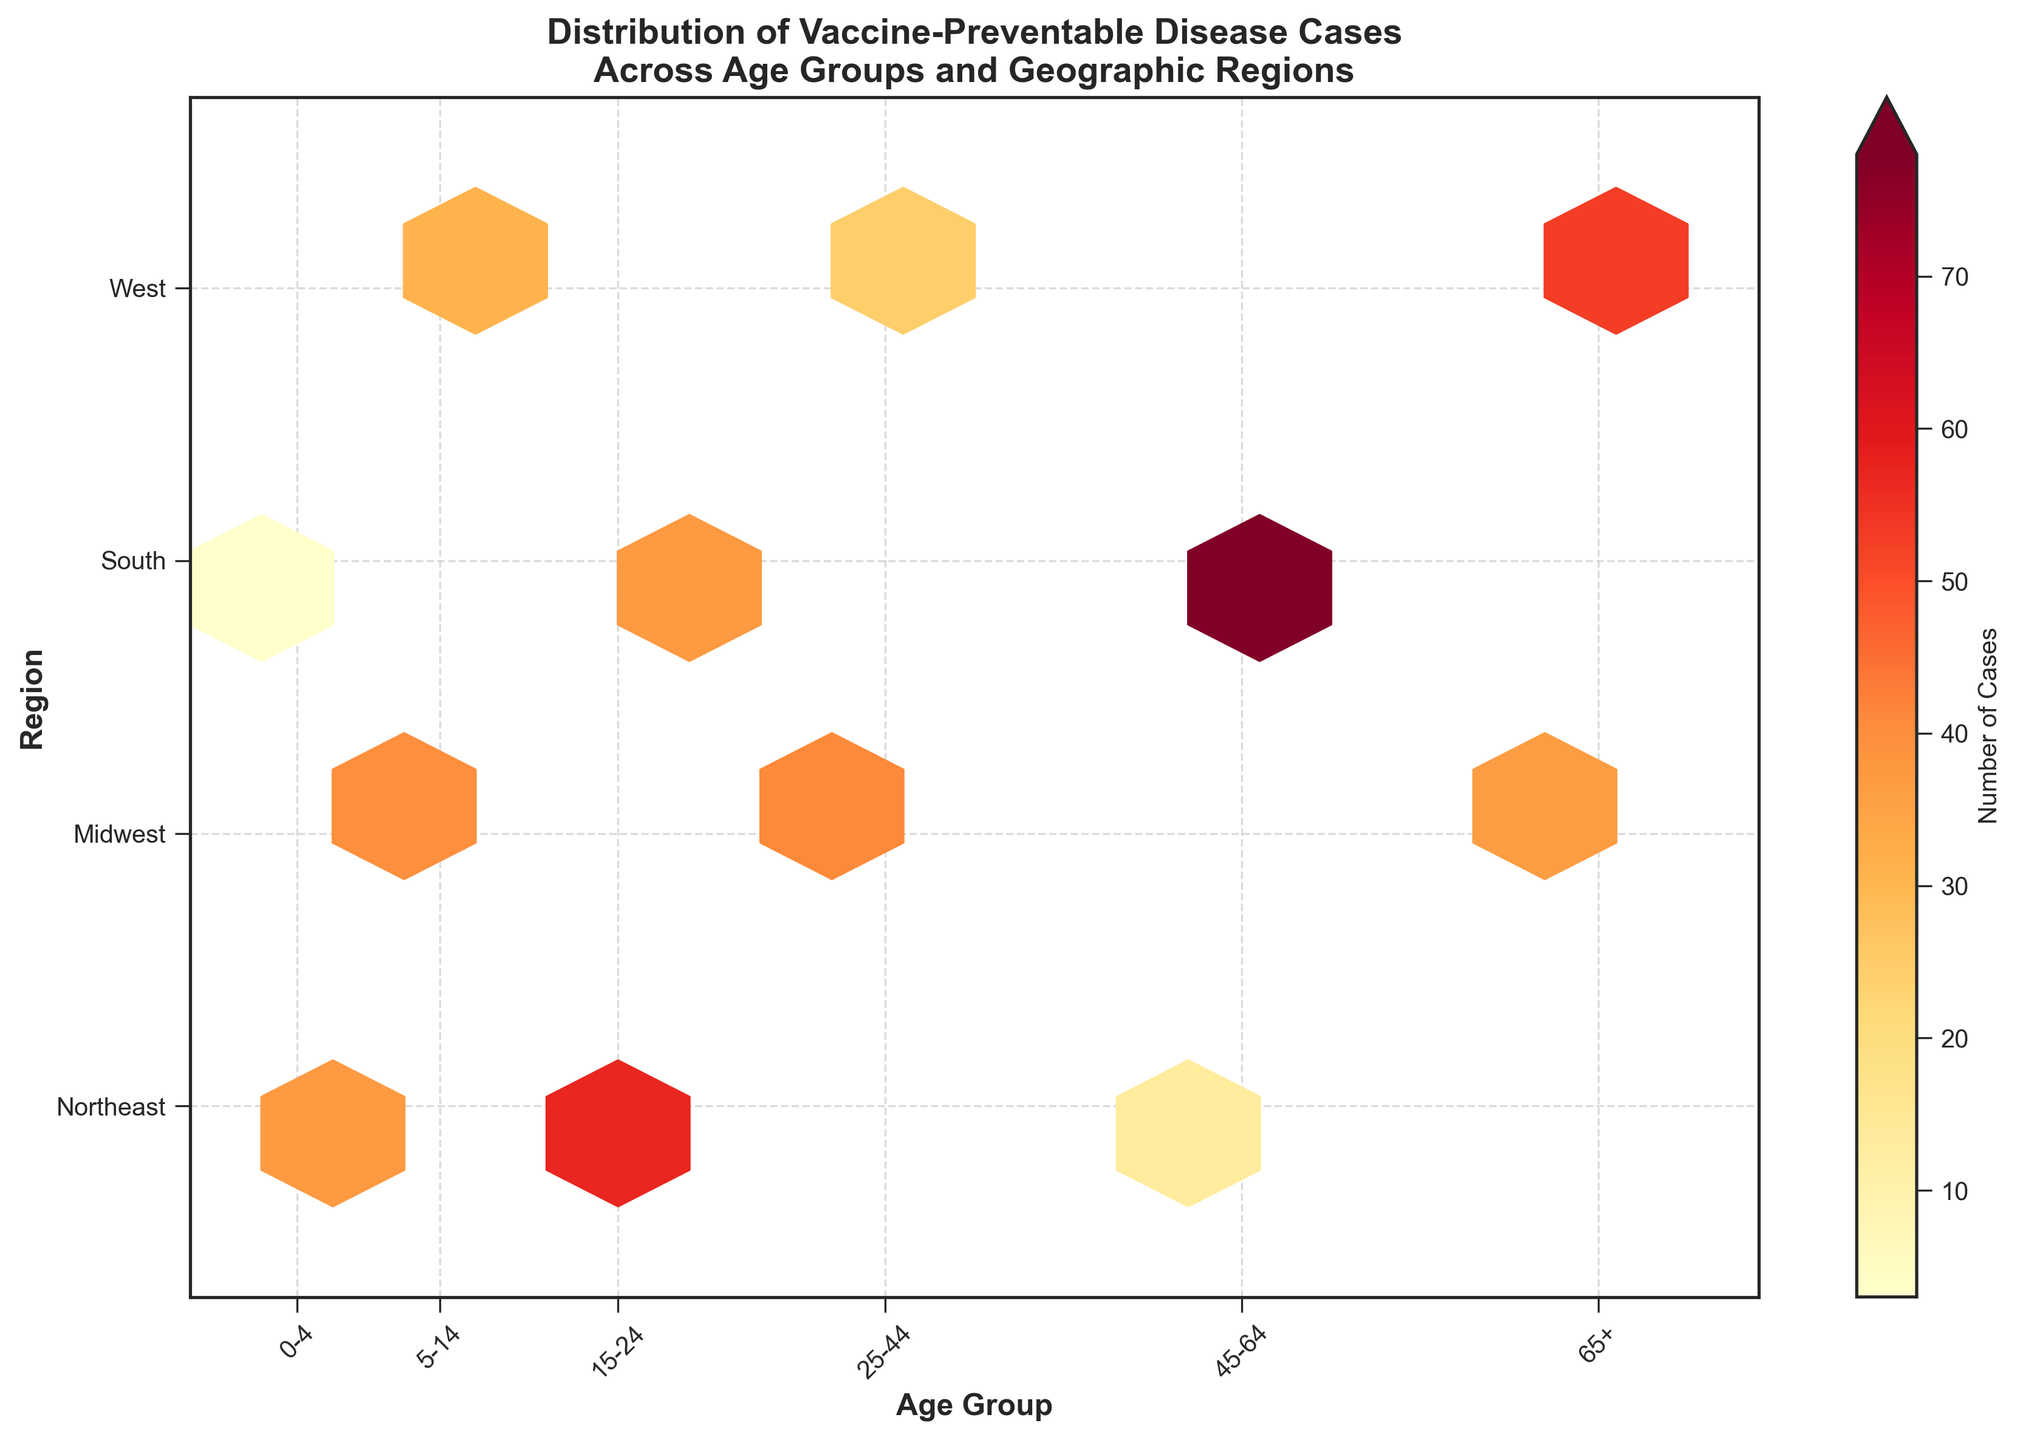How many age groups are represented in the plot? The x-axis has labels for six distinct age groups: '0-4', '5-14', '15-24', '25-44', '45-64', and '65+'. So there are six age groups represented.
Answer: 6 Which region has the highest number of hexagons? By observing the plot, the region with the most hexagonal bins is the Midwest, as it shows multiple hexagons across the different age groups.
Answer: Midwest What is the total number of cases for the age group 0-4 across all regions? Summing up the cases from the '0-4' age group: 45 (Northeast) + 3 (South) + 29 (Northeast) = 77 cases.
Answer: 77 Which age group and region combination has the highest number of cases? The hexagon with the deepest color (indicating the highest number of cases) is located at the age group '45-64' and region 'South'. This signifies the highest number of cases.
Answer: Age group '45-64' in the South How does the number of cases in the West compare between the age groups 5-14 and 65+? The plot shows a hexagon with lighter color for the West at age group '5-14' (31 cases) compared to the darker hexagon at age group '65+' (53 cases). Thus, the West has more cases in the '65+' age group compared to '5-14'.
Answer: More cases in 65+ In which regions is the disease 'Pneumococcal' occurring, and what are the case numbers for each? From the data, 'Pneumococcal' cases appear in the 'Midwest' for the age group '25-44'. It is seen as a single heatmap unit at this position, indicating 41 cases.
Answer: Midwest: 41 What is the color pattern used to represent the number of cases? The color pattern used in the hexbin plot ranges from yellow (indicating fewer cases) to red (indicating more cases).
Answer: Yellow to Red Which age group in the Northeast has the most number of cases? The hexagon with the deepest color in the Northeast region is at the '15-24' age group, indicating the highest number of cases within this region.
Answer: Age group '15-24' What is the median value of the number of cases across all hexagons? Listing the cases from all hexagon bins: (45, 62, 38, 27, 15, 9, 3, 31, 57, 41, 78, 53, 29, 18, 36, 22, 11, 64) and finding the median by sorting these values and picking the middle ones: the median value is (31+36)/2 = 33.5
Answer: 33.5 